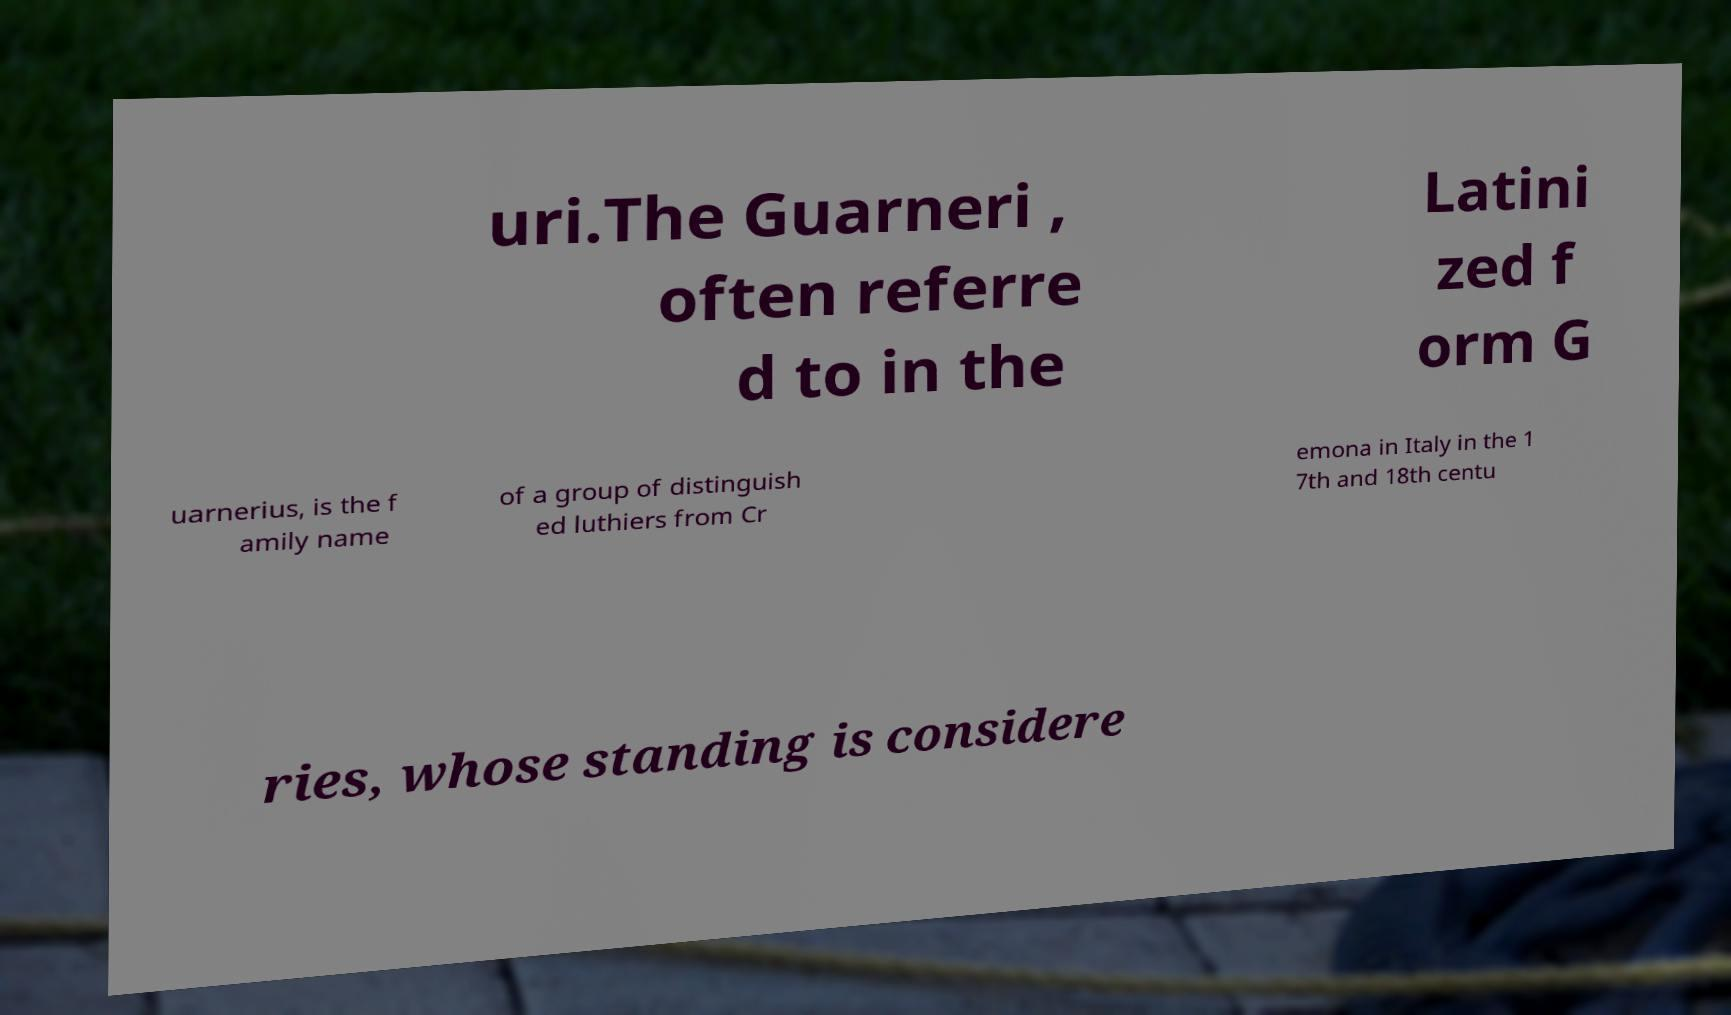There's text embedded in this image that I need extracted. Can you transcribe it verbatim? uri.The Guarneri , often referre d to in the Latini zed f orm G uarnerius, is the f amily name of a group of distinguish ed luthiers from Cr emona in Italy in the 1 7th and 18th centu ries, whose standing is considere 